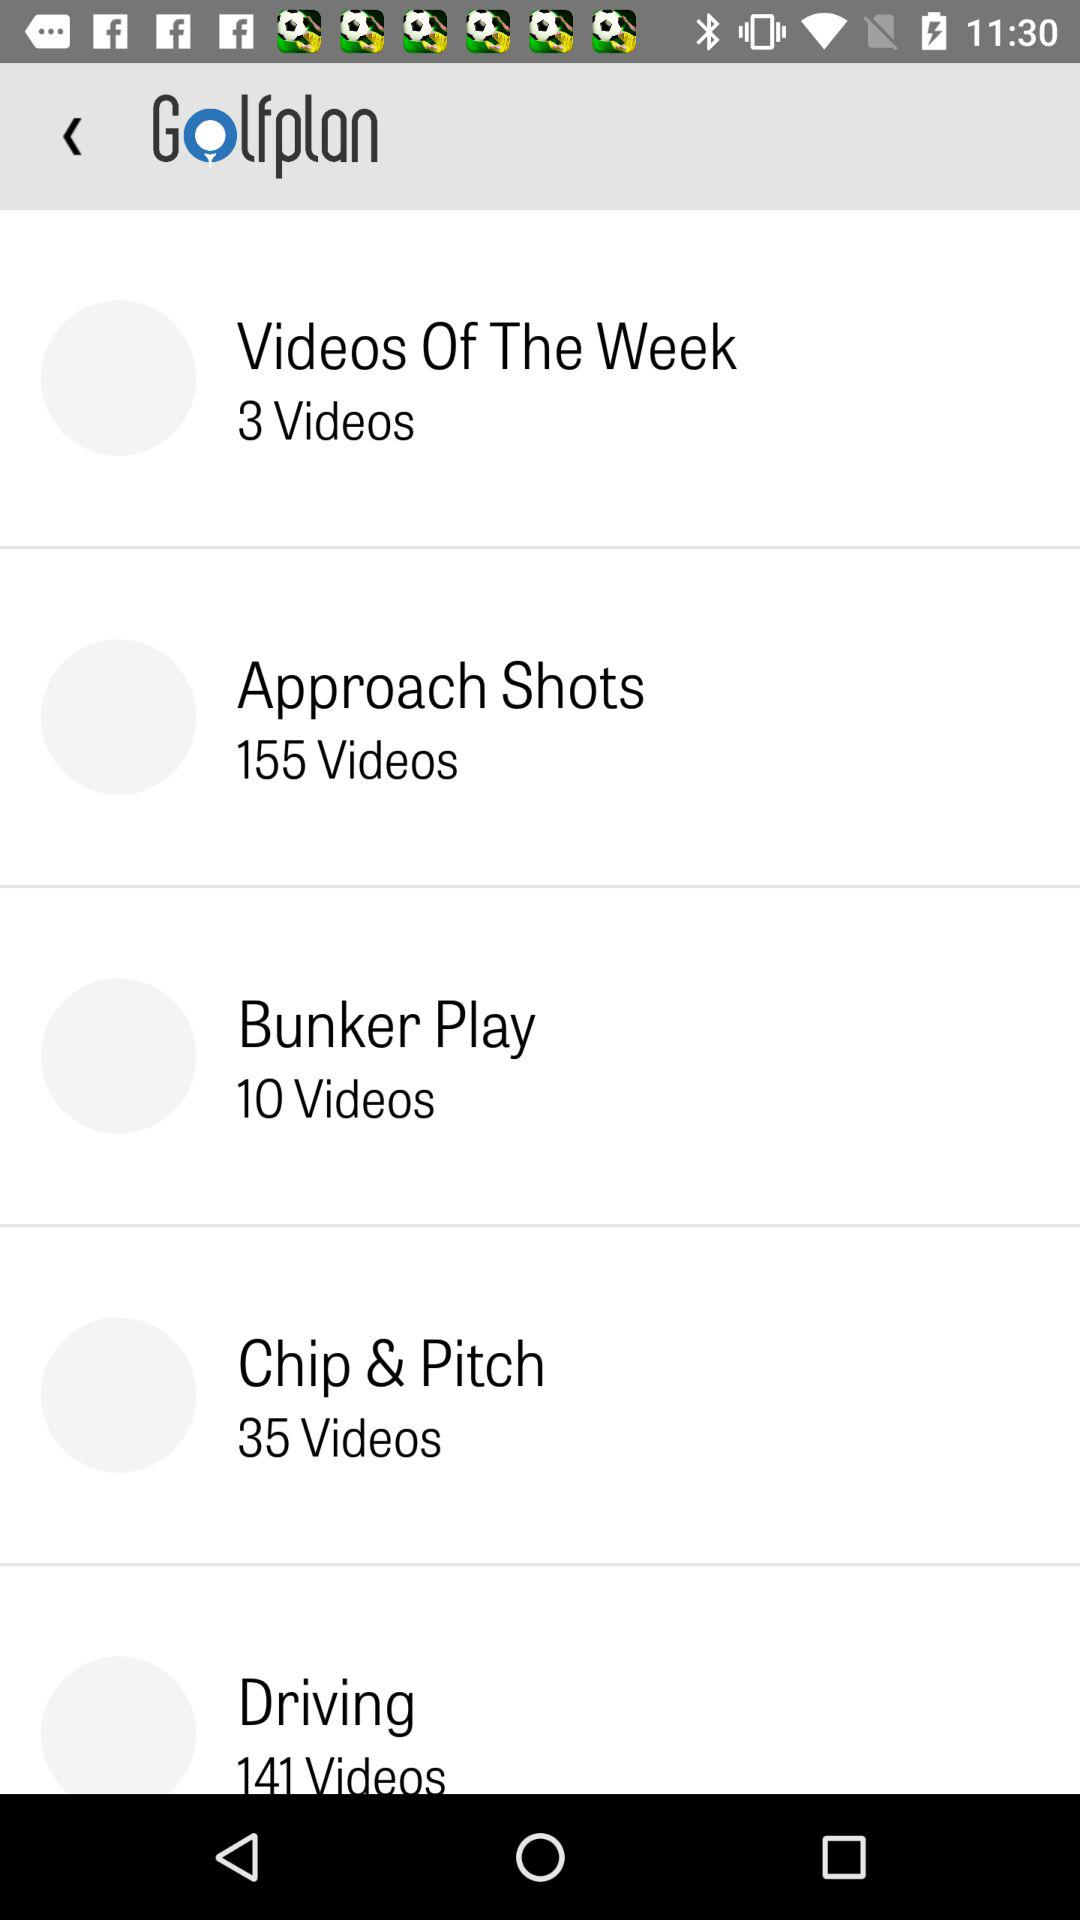How many more videos are there in the Chip & Pitch section than in the Bunker Play section?
Answer the question using a single word or phrase. 25 